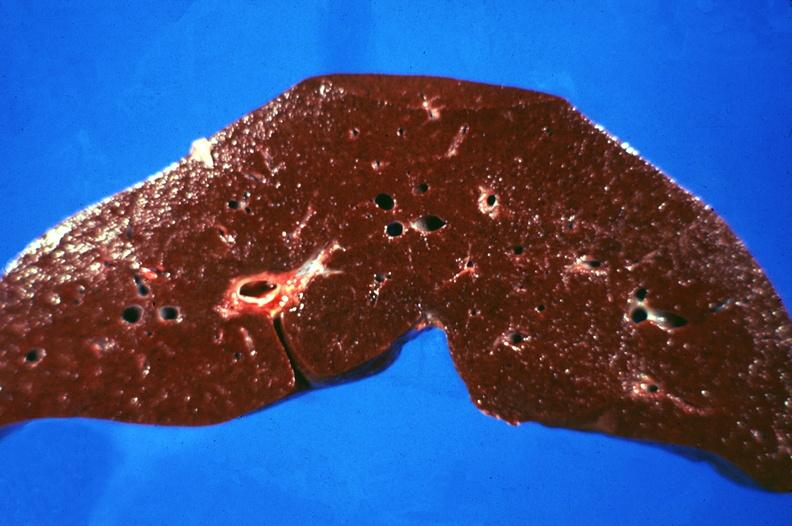does this image show liver, hemochromatosis?
Answer the question using a single word or phrase. Yes 